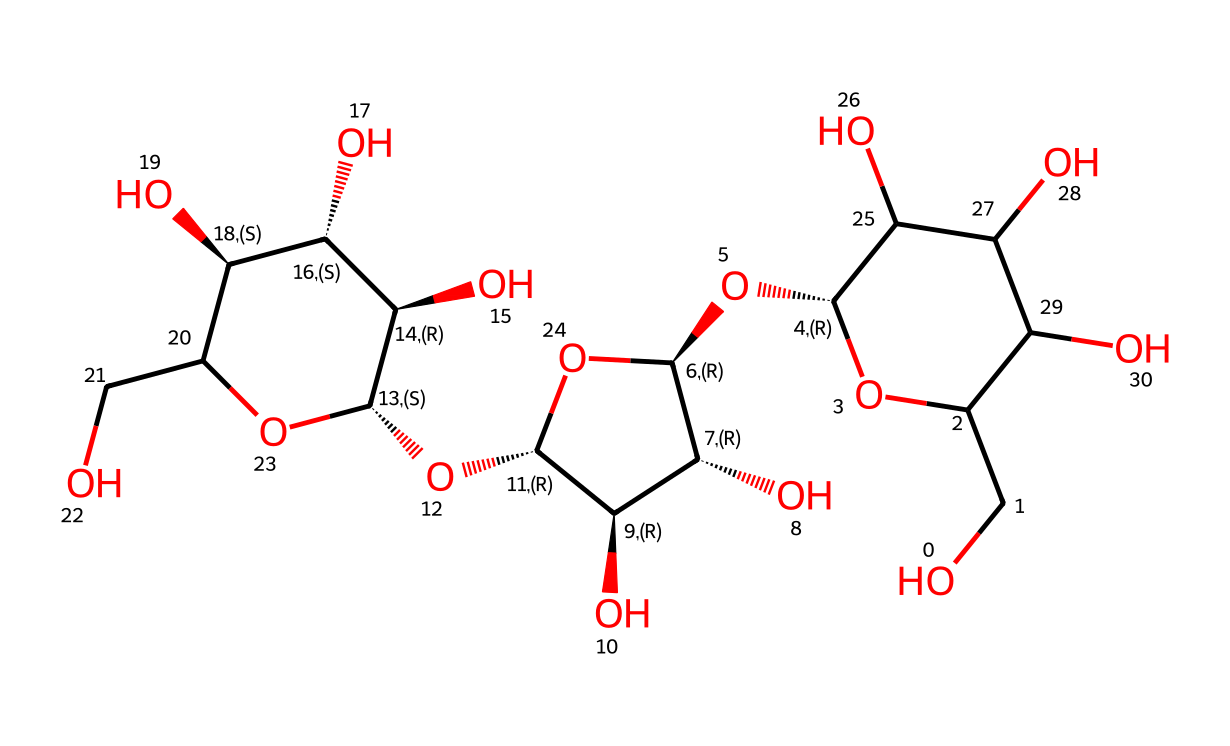What is the molecular formula of cellulose represented by this SMILES? The molecular formula can be determined by counting the number of each type of atom present in the chemical structure. From the SMILES notation, we can identify multiple carbon (C), hydrogen (H), and oxygen (O) atoms. The final count gives us C6H10O5, which corresponds to the repeat unit of cellulose.
Answer: C6H10O5 How many rings are present in the cellulose structure? By analyzing the structure, we can identify the cyclic (ring) formations due to the presence of the 'C@H' and 'O' atoms repeating in a particular fashion. There are three distinct rings in the cellulose structure, showcasing its polysaccharide nature.
Answer: 3 What type of carbohydrate is cellulose classified as? The structure's repeating units of glucose derivatives indicate that cellulose is a polysaccharide. It consists of long chains of monosaccharide units, specifically glucose, linked together, characterizing it as a carbohydrate.
Answer: polysaccharide What primary functional groups are present in cellulose? Observing the chemical structure, we notice hydroxyl (-OH) groups attached to the carbon skeleton, which are responsible for cellulose's hydrophilic properties. The presence of these groups also leads to hydrogen bonding between cellulose molecules.
Answer: hydroxyl groups Which characteristic of cellulose allows it to form strong fibers? Cellulose possesses a long chain structure that facilitates intermolecular hydrogen bonding, lending strength to its fibers. The alignment of the chains allows for enhanced tensile strength, which is essential for fiber formation.
Answer: hydrogen bonding How does the structure of cellulose differ from that of starch? Cellulose consists of beta-glucose units that create a straight-chain structure, whereas starch is made up of alpha-glucose units resulting in a branched structure. This fundamental difference in glycosidic linkages leads to distinct physical properties.
Answer: different glycosidic linkages 